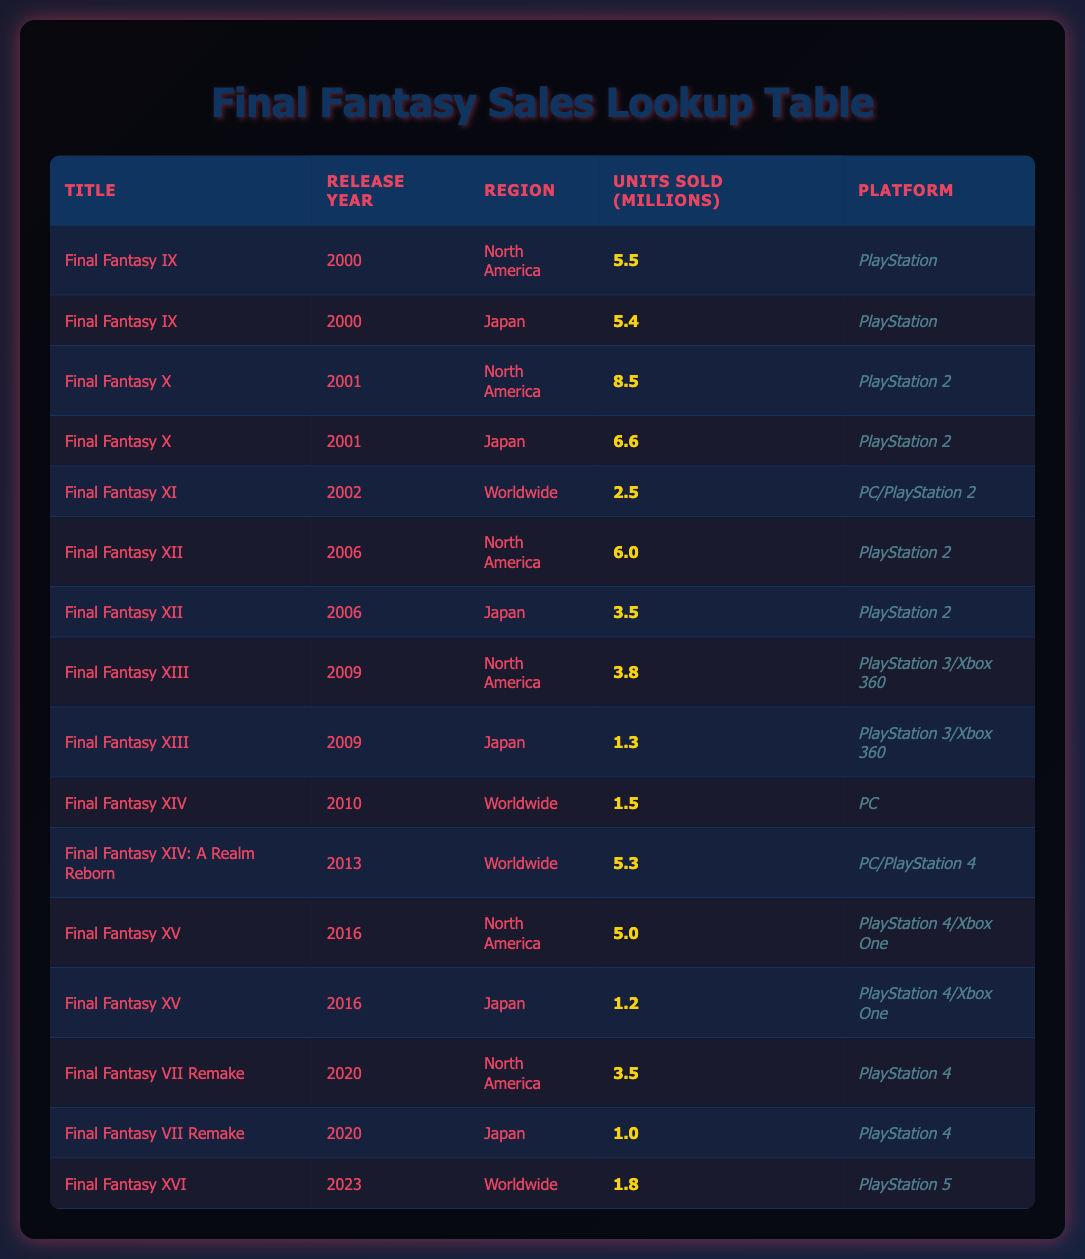What is the total number of units sold for Final Fantasy VII Remake in North America and Japan? The units sold for Final Fantasy VII Remake in North America is 3.5 million and in Japan is 1.0 million. To find the total, add these two values: 3.5 + 1.0 = 4.5 million.
Answer: 4.5 million In which region did Final Fantasy X sell the most units? Final Fantasy X sold 8.5 million units in North America and 6.6 million units in Japan. Since 8.5 is greater than 6.6, it sold the most units in North America.
Answer: North America Did Final Fantasy XI achieve higher sales than Final Fantasy XIV in their respective worldwide releases? Final Fantasy XI sold 2.5 million units worldwide while Final Fantasy XIV sold 1.5 million units worldwide. Since 2.5 is greater than 1.5, Final Fantasy XI achieved higher sales.
Answer: Yes What was the average number of units sold for Final Fantasy XIII in North America and Japan? For North America, Final Fantasy XIII sold 3.8 million units and in Japan, it sold 1.3 million units. To find the average, sum the units sold (3.8 + 1.3 = 5.1) and divide by the number of regions (2). Thus, 5.1/2 = 2.55 million.
Answer: 2.55 million Which game had the highest sales in 2001? In 2001, Final Fantasy X sold 8.5 million units in North America and 6.6 million in Japan. The highest sales are from Final Fantasy X in North America with 8.5 million units.
Answer: Final Fantasy X 